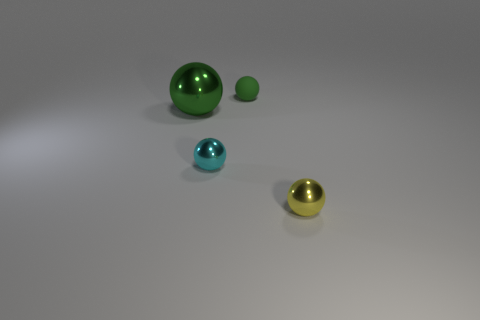What number of other yellow metal things have the same size as the yellow metallic thing?
Give a very brief answer. 0. Are there any green spheres on the left side of the sphere that is behind the large sphere?
Ensure brevity in your answer.  Yes. What number of objects are big green shiny objects or tiny yellow metal objects?
Give a very brief answer. 2. What is the color of the ball that is to the left of the tiny sphere to the left of the tiny green rubber thing right of the small cyan shiny sphere?
Ensure brevity in your answer.  Green. Is the green rubber thing the same size as the cyan sphere?
Your answer should be compact. Yes. How many things are either balls behind the yellow ball or small objects that are in front of the green metal sphere?
Your answer should be compact. 4. What is the material of the small yellow sphere that is in front of the green sphere that is in front of the green matte object?
Offer a terse response. Metal. How many other things are the same material as the tiny green ball?
Your response must be concise. 0. Does the big metal object have the same shape as the small green matte object?
Provide a succinct answer. Yes. What size is the cyan ball that is to the left of the small green ball?
Give a very brief answer. Small. 